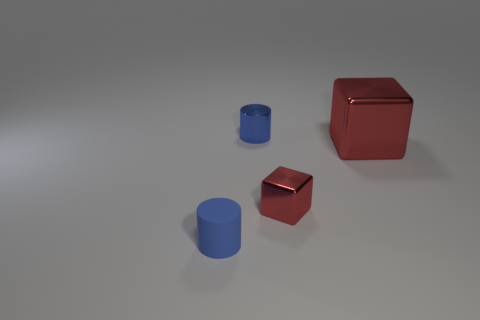Add 1 blue rubber cylinders. How many objects exist? 5 Subtract all blue metal cylinders. Subtract all large red blocks. How many objects are left? 2 Add 2 tiny blue rubber things. How many tiny blue rubber things are left? 3 Add 2 small matte cylinders. How many small matte cylinders exist? 3 Subtract 0 brown cubes. How many objects are left? 4 